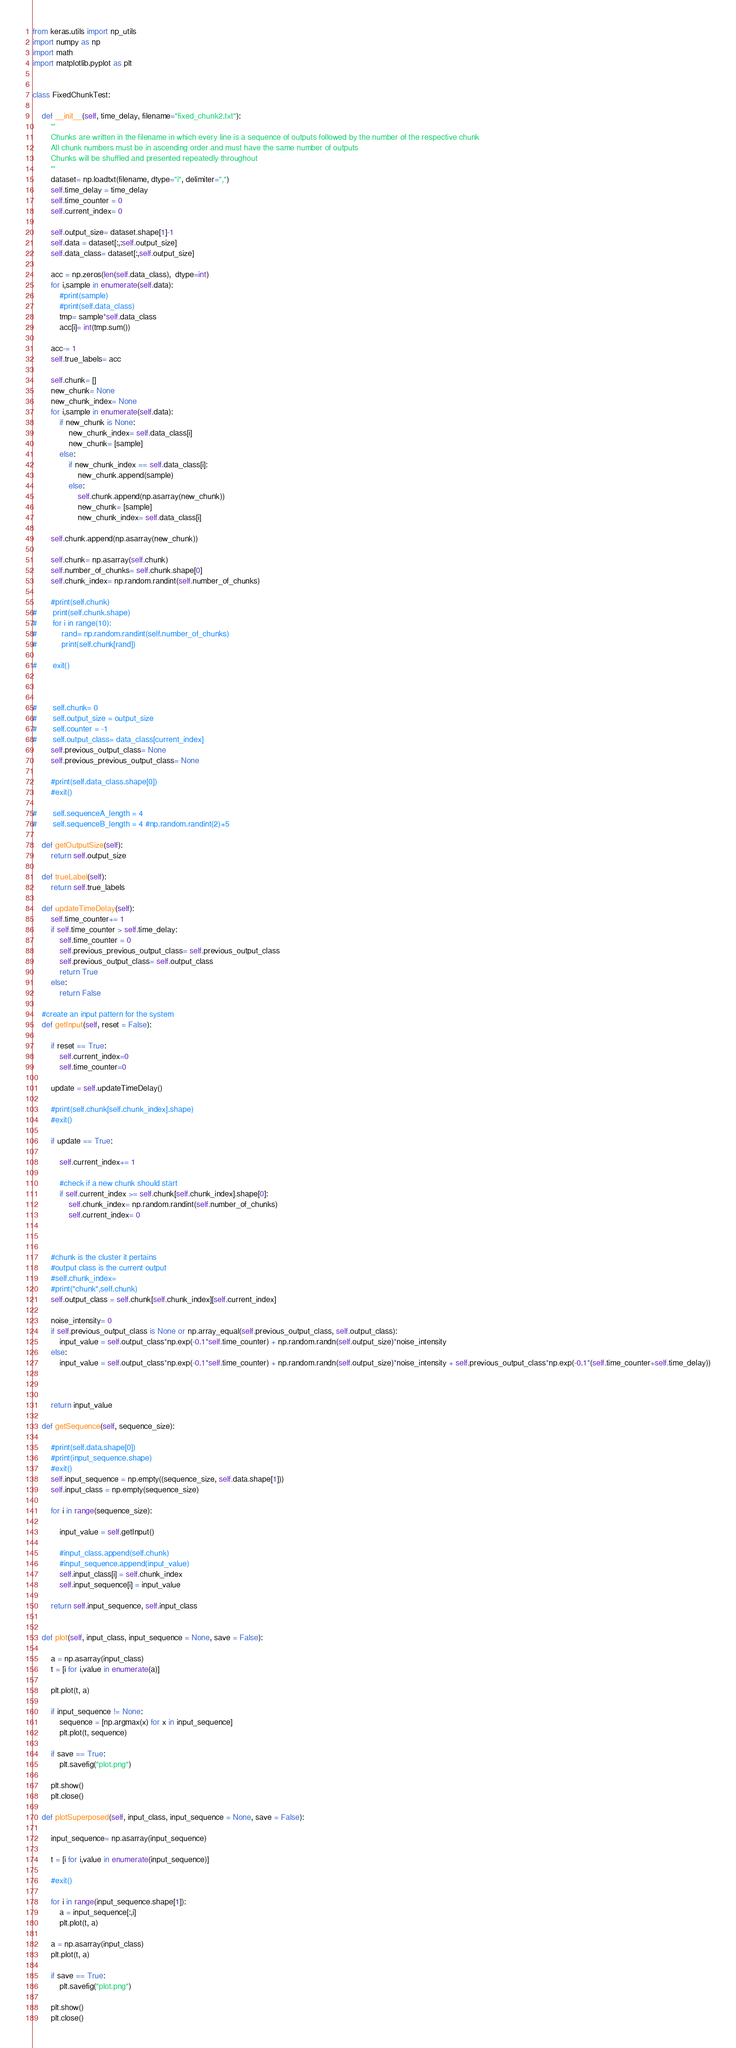Convert code to text. <code><loc_0><loc_0><loc_500><loc_500><_Python_>from keras.utils import np_utils
import numpy as np
import math
import matplotlib.pyplot as plt


class FixedChunkTest:
	
	def __init__(self, time_delay, filename="fixed_chunk2.txt"):
		'''
		Chunks are written in the filename in which every line is a sequence of outputs followed by the number of the respective chunk
		All chunk numbers must be in ascending order and must have the same number of outputs
		Chunks will be shuffled and presented repeatedly throughout
		'''
		dataset= np.loadtxt(filename, dtype="i", delimiter=",")
		self.time_delay = time_delay
		self.time_counter = 0
		self.current_index= 0

		self.output_size= dataset.shape[1]-1
		self.data = dataset[:,:self.output_size]
		self.data_class= dataset[:,self.output_size]

		acc = np.zeros(len(self.data_class),  dtype=int)
		for i,sample in enumerate(self.data):
			#print(sample)
			#print(self.data_class)
			tmp= sample*self.data_class
			acc[i]= int(tmp.sum())
		
		acc-= 1
		self.true_labels= acc

		self.chunk= []
		new_chunk= None
		new_chunk_index= None
		for i,sample in enumerate(self.data):
			if new_chunk is None:
				new_chunk_index= self.data_class[i]
				new_chunk= [sample]
			else:
				if new_chunk_index == self.data_class[i]:
					new_chunk.append(sample)
				else:
					self.chunk.append(np.asarray(new_chunk))
					new_chunk= [sample]
					new_chunk_index= self.data_class[i]

		self.chunk.append(np.asarray(new_chunk))

		self.chunk= np.asarray(self.chunk)
		self.number_of_chunks= self.chunk.shape[0]
		self.chunk_index= np.random.randint(self.number_of_chunks)
		
		#print(self.chunk)
#		print(self.chunk.shape)
#		for i in range(10):
#			rand= np.random.randint(self.number_of_chunks)
#			print(self.chunk[rand])

#		exit()



#		self.chunk= 0
#		self.output_size = output_size
#		self.counter = -1
#		self.output_class= data_class[current_index]
		self.previous_output_class= None
		self.previous_previous_output_class= None
			
		#print(self.data_class.shape[0])
		#exit()

#		self.sequenceA_length = 4
#		self.sequenceB_length = 4 #np.random.randint(2)+5
	
	def getOutputSize(self):
		return self.output_size
	
	def trueLabel(self):
		return self.true_labels

	def updateTimeDelay(self):
		self.time_counter+= 1
		if self.time_counter > self.time_delay:
			self.time_counter = 0 
			self.previous_previous_output_class= self.previous_output_class
			self.previous_output_class= self.output_class
			return True
		else:
			return False

	#create an input pattern for the system
	def getInput(self, reset = False):
		
		if reset == True:
			self.current_index=0
			self.time_counter=0

		update = self.updateTimeDelay()
		
		#print(self.chunk[self.chunk_index].shape)
		#exit()

		if update == True:
			
			self.current_index+= 1

			#check if a new chunk should start
			if self.current_index >= self.chunk[self.chunk_index].shape[0]:
				self.chunk_index= np.random.randint(self.number_of_chunks)
				self.current_index= 0
			
		
					
		#chunk is the cluster it pertains
		#output class is the current output
		#self.chunk_index= 
		#print("chunk",self.chunk)
		self.output_class = self.chunk[self.chunk_index][self.current_index]
		
		noise_intensity= 0
		if self.previous_output_class is None or np.array_equal(self.previous_output_class, self.output_class):
			input_value = self.output_class*np.exp(-0.1*self.time_counter) + np.random.randn(self.output_size)*noise_intensity
		else:
			input_value = self.output_class*np.exp(-0.1*self.time_counter) + np.random.randn(self.output_size)*noise_intensity + self.previous_output_class*np.exp(-0.1*(self.time_counter+self.time_delay))



		return input_value

	def getSequence(self, sequence_size):
	
		#print(self.data.shape[0])
		#print(input_sequence.shape)
		#exit()
		self.input_sequence = np.empty((sequence_size, self.data.shape[1]))
		self.input_class = np.empty(sequence_size)
		
		for i in range(sequence_size):
			
			input_value = self.getInput()
			
			#input_class.append(self.chunk)
			#input_sequence.append(input_value)
			self.input_class[i] = self.chunk_index
			self.input_sequence[i] = input_value

		return self.input_sequence, self.input_class

	
	def plot(self, input_class, input_sequence = None, save = False):
		
		a = np.asarray(input_class)
		t = [i for i,value in enumerate(a)]

		plt.plot(t, a)
		
		if input_sequence != None:
			sequence = [np.argmax(x) for x in input_sequence]
			plt.plot(t, sequence)

		if save == True:
			plt.savefig("plot.png")
		
		plt.show()
		plt.close()
	
	def plotSuperposed(self, input_class, input_sequence = None, save = False):
	
		input_sequence= np.asarray(input_sequence)
		
		t = [i for i,value in enumerate(input_sequence)]

		#exit()

		for i in range(input_sequence.shape[1]):
			a = input_sequence[:,i]
			plt.plot(t, a)
		
		a = np.asarray(input_class)
		plt.plot(t, a)

		if save == True:
			plt.savefig("plot.png")
		
		plt.show()
		plt.close()

</code> 